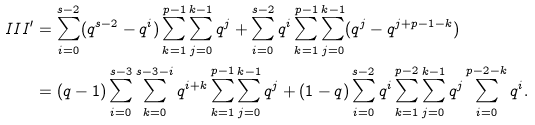<formula> <loc_0><loc_0><loc_500><loc_500>I I I ^ { \prime } & = \sum _ { i = 0 } ^ { s - 2 } ( q ^ { s - 2 } - q ^ { i } ) \sum _ { k = 1 } ^ { p - 1 } \sum _ { j = 0 } ^ { k - 1 } q ^ { j } + \sum _ { i = 0 } ^ { s - 2 } q ^ { i } \sum _ { k = 1 } ^ { p - 1 } \sum _ { j = 0 } ^ { k - 1 } ( q ^ { j } - q ^ { j + p - 1 - k } ) \\ & = ( q - 1 ) \sum _ { i = 0 } ^ { s - 3 } \sum _ { k = 0 } ^ { s - 3 - i } q ^ { i + k } \sum _ { k = 1 } ^ { p - 1 } \sum _ { j = 0 } ^ { k - 1 } q ^ { j } + ( 1 - q ) \sum _ { i = 0 } ^ { s - 2 } q ^ { i } \sum _ { k = 1 } ^ { p - 2 } \sum _ { j = 0 } ^ { k - 1 } q ^ { j } \sum _ { i = 0 } ^ { p - 2 - k } q ^ { i } .</formula> 